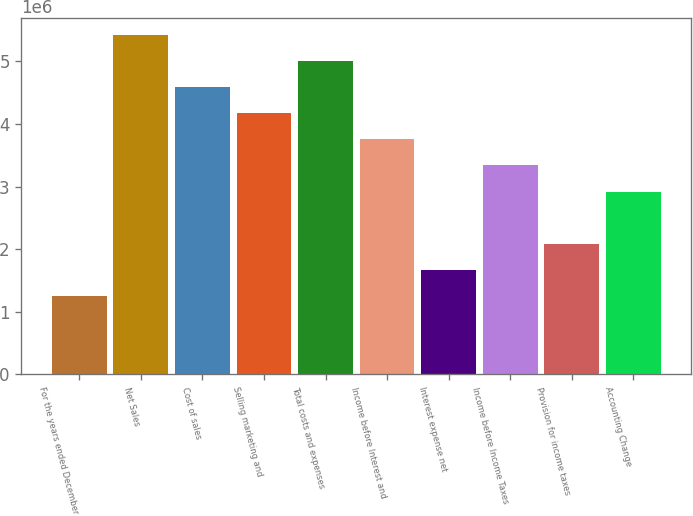Convert chart. <chart><loc_0><loc_0><loc_500><loc_500><bar_chart><fcel>For the years ended December<fcel>Net Sales<fcel>Cost of sales<fcel>Selling marketing and<fcel>Total costs and expenses<fcel>Income before Interest and<fcel>Interest expense net<fcel>Income before Income Taxes<fcel>Provision for income taxes<fcel>Accounting Change<nl><fcel>1.25177e+06<fcel>5.42432e+06<fcel>4.58981e+06<fcel>4.17255e+06<fcel>5.00706e+06<fcel>3.7553e+06<fcel>1.66902e+06<fcel>3.33804e+06<fcel>2.08628e+06<fcel>2.92079e+06<nl></chart> 